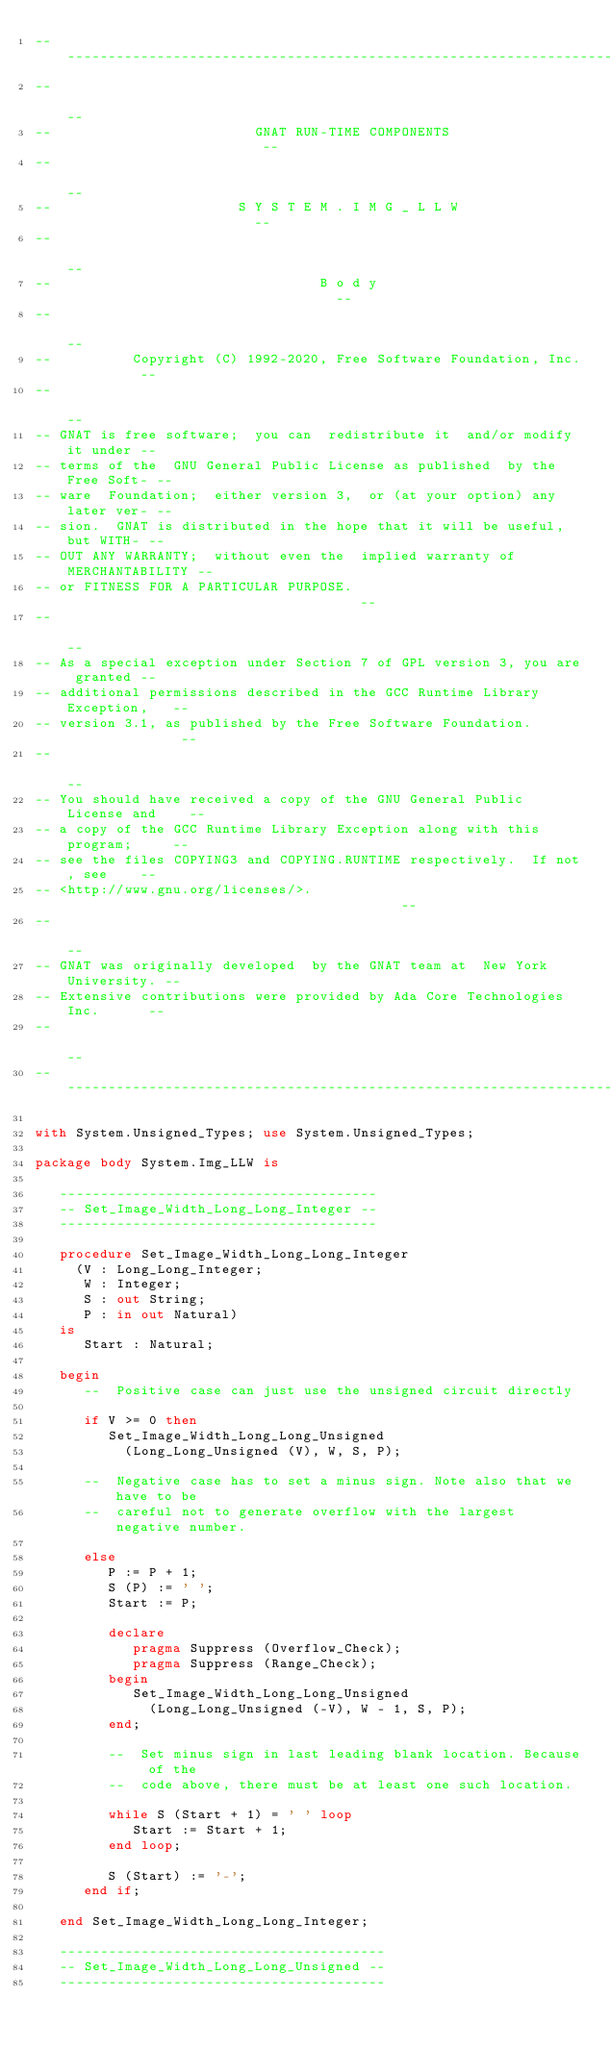<code> <loc_0><loc_0><loc_500><loc_500><_Ada_>------------------------------------------------------------------------------
--                                                                          --
--                         GNAT RUN-TIME COMPONENTS                         --
--                                                                          --
--                       S Y S T E M . I M G _ L L W                        --
--                                                                          --
--                                 B o d y                                  --
--                                                                          --
--          Copyright (C) 1992-2020, Free Software Foundation, Inc.         --
--                                                                          --
-- GNAT is free software;  you can  redistribute it  and/or modify it under --
-- terms of the  GNU General Public License as published  by the Free Soft- --
-- ware  Foundation;  either version 3,  or (at your option) any later ver- --
-- sion.  GNAT is distributed in the hope that it will be useful, but WITH- --
-- OUT ANY WARRANTY;  without even the  implied warranty of MERCHANTABILITY --
-- or FITNESS FOR A PARTICULAR PURPOSE.                                     --
--                                                                          --
-- As a special exception under Section 7 of GPL version 3, you are granted --
-- additional permissions described in the GCC Runtime Library Exception,   --
-- version 3.1, as published by the Free Software Foundation.               --
--                                                                          --
-- You should have received a copy of the GNU General Public License and    --
-- a copy of the GCC Runtime Library Exception along with this program;     --
-- see the files COPYING3 and COPYING.RUNTIME respectively.  If not, see    --
-- <http://www.gnu.org/licenses/>.                                          --
--                                                                          --
-- GNAT was originally developed  by the GNAT team at  New York University. --
-- Extensive contributions were provided by Ada Core Technologies Inc.      --
--                                                                          --
------------------------------------------------------------------------------

with System.Unsigned_Types; use System.Unsigned_Types;

package body System.Img_LLW is

   ---------------------------------------
   -- Set_Image_Width_Long_Long_Integer --
   ---------------------------------------

   procedure Set_Image_Width_Long_Long_Integer
     (V : Long_Long_Integer;
      W : Integer;
      S : out String;
      P : in out Natural)
   is
      Start : Natural;

   begin
      --  Positive case can just use the unsigned circuit directly

      if V >= 0 then
         Set_Image_Width_Long_Long_Unsigned
           (Long_Long_Unsigned (V), W, S, P);

      --  Negative case has to set a minus sign. Note also that we have to be
      --  careful not to generate overflow with the largest negative number.

      else
         P := P + 1;
         S (P) := ' ';
         Start := P;

         declare
            pragma Suppress (Overflow_Check);
            pragma Suppress (Range_Check);
         begin
            Set_Image_Width_Long_Long_Unsigned
              (Long_Long_Unsigned (-V), W - 1, S, P);
         end;

         --  Set minus sign in last leading blank location. Because of the
         --  code above, there must be at least one such location.

         while S (Start + 1) = ' ' loop
            Start := Start + 1;
         end loop;

         S (Start) := '-';
      end if;

   end Set_Image_Width_Long_Long_Integer;

   ----------------------------------------
   -- Set_Image_Width_Long_Long_Unsigned --
   ----------------------------------------
</code> 